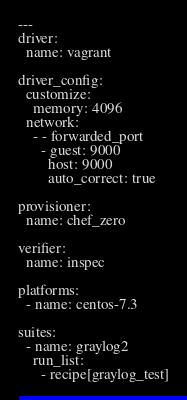<code> <loc_0><loc_0><loc_500><loc_500><_YAML_>---
driver:
  name: vagrant

driver_config:
  customize:
    memory: 4096
  network:
    - - forwarded_port
      - guest: 9000
        host: 9000
        auto_correct: true

provisioner:
  name: chef_zero

verifier:
  name: inspec

platforms:
  - name: centos-7.3

suites:
  - name: graylog2
    run_list:
      - recipe[graylog_test]
</code> 